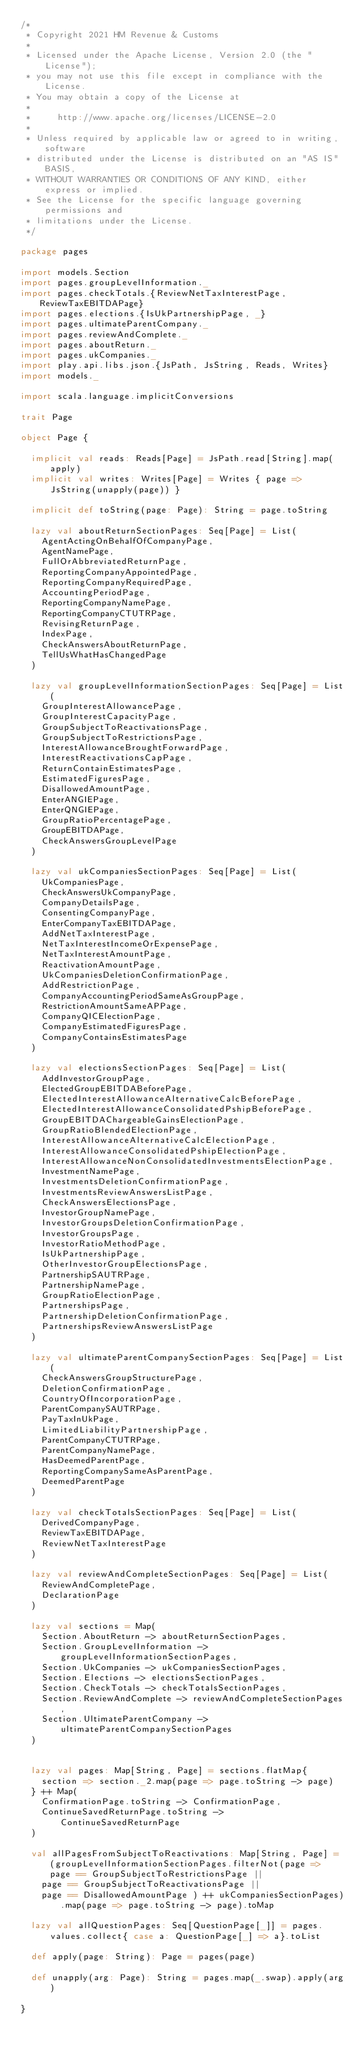<code> <loc_0><loc_0><loc_500><loc_500><_Scala_>/*
 * Copyright 2021 HM Revenue & Customs
 *
 * Licensed under the Apache License, Version 2.0 (the "License");
 * you may not use this file except in compliance with the License.
 * You may obtain a copy of the License at
 *
 *     http://www.apache.org/licenses/LICENSE-2.0
 *
 * Unless required by applicable law or agreed to in writing, software
 * distributed under the License is distributed on an "AS IS" BASIS,
 * WITHOUT WARRANTIES OR CONDITIONS OF ANY KIND, either express or implied.
 * See the License for the specific language governing permissions and
 * limitations under the License.
 */

package pages

import models.Section
import pages.groupLevelInformation._
import pages.checkTotals.{ReviewNetTaxInterestPage, ReviewTaxEBITDAPage}
import pages.elections.{IsUkPartnershipPage, _}
import pages.ultimateParentCompany._
import pages.reviewAndComplete._
import pages.aboutReturn._
import pages.ukCompanies._
import play.api.libs.json.{JsPath, JsString, Reads, Writes}
import models._

import scala.language.implicitConversions

trait Page

object Page {
  
  implicit val reads: Reads[Page] = JsPath.read[String].map(apply)
  implicit val writes: Writes[Page] = Writes { page => JsString(unapply(page)) }

  implicit def toString(page: Page): String = page.toString

  lazy val aboutReturnSectionPages: Seq[Page] = List(
    AgentActingOnBehalfOfCompanyPage,
    AgentNamePage,
    FullOrAbbreviatedReturnPage,
    ReportingCompanyAppointedPage,
    ReportingCompanyRequiredPage,
    AccountingPeriodPage,
    ReportingCompanyNamePage,
    ReportingCompanyCTUTRPage,
    RevisingReturnPage,
    IndexPage,
    CheckAnswersAboutReturnPage,
    TellUsWhatHasChangedPage
  )

  lazy val groupLevelInformationSectionPages: Seq[Page] = List(
    GroupInterestAllowancePage,
    GroupInterestCapacityPage,
    GroupSubjectToReactivationsPage,
    GroupSubjectToRestrictionsPage,
    InterestAllowanceBroughtForwardPage,
    InterestReactivationsCapPage,
    ReturnContainEstimatesPage,
    EstimatedFiguresPage,
    DisallowedAmountPage,
    EnterANGIEPage,
    EnterQNGIEPage,
    GroupRatioPercentagePage,
    GroupEBITDAPage,
    CheckAnswersGroupLevelPage
  )

  lazy val ukCompaniesSectionPages: Seq[Page] = List(
    UkCompaniesPage,
    CheckAnswersUkCompanyPage,
    CompanyDetailsPage,
    ConsentingCompanyPage,
    EnterCompanyTaxEBITDAPage,
    AddNetTaxInterestPage,
    NetTaxInterestIncomeOrExpensePage,
    NetTaxInterestAmountPage,
    ReactivationAmountPage,
    UkCompaniesDeletionConfirmationPage,
    AddRestrictionPage,
    CompanyAccountingPeriodSameAsGroupPage,
    RestrictionAmountSameAPPage,
    CompanyQICElectionPage,
    CompanyEstimatedFiguresPage,
    CompanyContainsEstimatesPage
  )

  lazy val electionsSectionPages: Seq[Page] = List(
    AddInvestorGroupPage,
    ElectedGroupEBITDABeforePage,
    ElectedInterestAllowanceAlternativeCalcBeforePage,
    ElectedInterestAllowanceConsolidatedPshipBeforePage,
    GroupEBITDAChargeableGainsElectionPage,
    GroupRatioBlendedElectionPage,
    InterestAllowanceAlternativeCalcElectionPage,
    InterestAllowanceConsolidatedPshipElectionPage,
    InterestAllowanceNonConsolidatedInvestmentsElectionPage,
    InvestmentNamePage,
    InvestmentsDeletionConfirmationPage,
    InvestmentsReviewAnswersListPage,
    CheckAnswersElectionsPage,
    InvestorGroupNamePage,
    InvestorGroupsDeletionConfirmationPage,
    InvestorGroupsPage,
    InvestorRatioMethodPage,
    IsUkPartnershipPage,
    OtherInvestorGroupElectionsPage,
    PartnershipSAUTRPage,
    PartnershipNamePage,
    GroupRatioElectionPage,
    PartnershipsPage,
    PartnershipDeletionConfirmationPage,
    PartnershipsReviewAnswersListPage
  )

  lazy val ultimateParentCompanySectionPages: Seq[Page] = List(
    CheckAnswersGroupStructurePage,
    DeletionConfirmationPage,
    CountryOfIncorporationPage,
    ParentCompanySAUTRPage,
    PayTaxInUkPage,
    LimitedLiabilityPartnershipPage,
    ParentCompanyCTUTRPage,
    ParentCompanyNamePage,
    HasDeemedParentPage,
    ReportingCompanySameAsParentPage,
    DeemedParentPage
  )

  lazy val checkTotalsSectionPages: Seq[Page] = List(
    DerivedCompanyPage,
    ReviewTaxEBITDAPage,
    ReviewNetTaxInterestPage
  )

  lazy val reviewAndCompleteSectionPages: Seq[Page] = List(
    ReviewAndCompletePage,
    DeclarationPage
  )

  lazy val sections = Map(
    Section.AboutReturn -> aboutReturnSectionPages,
    Section.GroupLevelInformation -> groupLevelInformationSectionPages,
    Section.UkCompanies -> ukCompaniesSectionPages,
    Section.Elections -> electionsSectionPages,
    Section.CheckTotals -> checkTotalsSectionPages,
    Section.ReviewAndComplete -> reviewAndCompleteSectionPages,
    Section.UltimateParentCompany -> ultimateParentCompanySectionPages
  )

  
  lazy val pages: Map[String, Page] = sections.flatMap{
    section => section._2.map(page => page.toString -> page)
  } ++ Map(
    ConfirmationPage.toString -> ConfirmationPage,
    ContinueSavedReturnPage.toString -> ContinueSavedReturnPage
  )

  val allPagesFromSubjectToReactivations: Map[String, Page] = (groupLevelInformationSectionPages.filterNot(page => page == GroupSubjectToRestrictionsPage ||
    page == GroupSubjectToReactivationsPage ||
    page == DisallowedAmountPage ) ++ ukCompaniesSectionPages).map(page => page.toString -> page).toMap

  lazy val allQuestionPages: Seq[QuestionPage[_]] = pages.values.collect{ case a: QuestionPage[_] => a}.toList

  def apply(page: String): Page = pages(page)

  def unapply(arg: Page): String = pages.map(_.swap).apply(arg)

}
</code> 